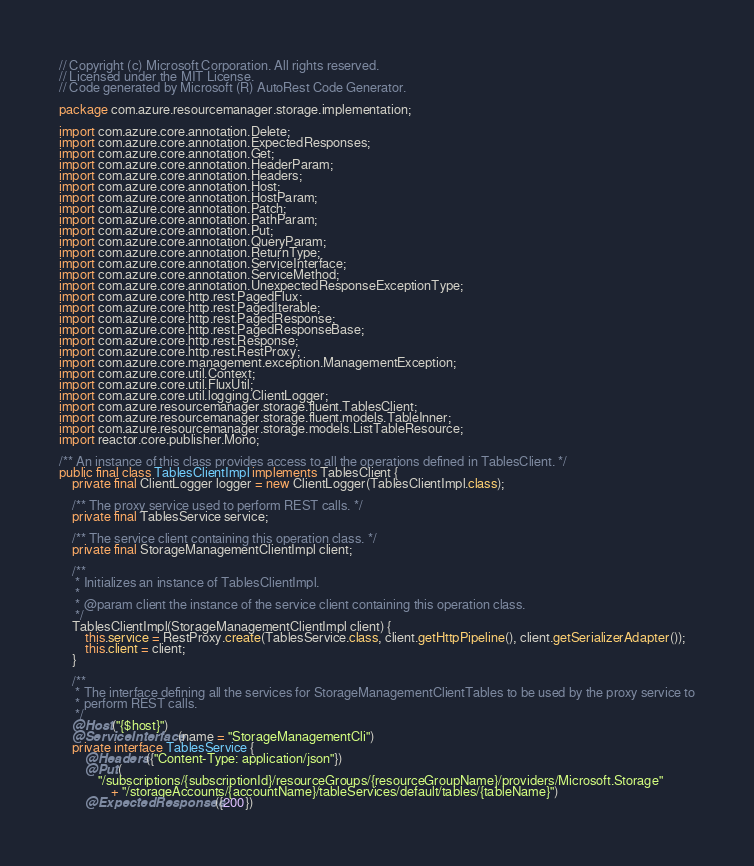Convert code to text. <code><loc_0><loc_0><loc_500><loc_500><_Java_>// Copyright (c) Microsoft Corporation. All rights reserved.
// Licensed under the MIT License.
// Code generated by Microsoft (R) AutoRest Code Generator.

package com.azure.resourcemanager.storage.implementation;

import com.azure.core.annotation.Delete;
import com.azure.core.annotation.ExpectedResponses;
import com.azure.core.annotation.Get;
import com.azure.core.annotation.HeaderParam;
import com.azure.core.annotation.Headers;
import com.azure.core.annotation.Host;
import com.azure.core.annotation.HostParam;
import com.azure.core.annotation.Patch;
import com.azure.core.annotation.PathParam;
import com.azure.core.annotation.Put;
import com.azure.core.annotation.QueryParam;
import com.azure.core.annotation.ReturnType;
import com.azure.core.annotation.ServiceInterface;
import com.azure.core.annotation.ServiceMethod;
import com.azure.core.annotation.UnexpectedResponseExceptionType;
import com.azure.core.http.rest.PagedFlux;
import com.azure.core.http.rest.PagedIterable;
import com.azure.core.http.rest.PagedResponse;
import com.azure.core.http.rest.PagedResponseBase;
import com.azure.core.http.rest.Response;
import com.azure.core.http.rest.RestProxy;
import com.azure.core.management.exception.ManagementException;
import com.azure.core.util.Context;
import com.azure.core.util.FluxUtil;
import com.azure.core.util.logging.ClientLogger;
import com.azure.resourcemanager.storage.fluent.TablesClient;
import com.azure.resourcemanager.storage.fluent.models.TableInner;
import com.azure.resourcemanager.storage.models.ListTableResource;
import reactor.core.publisher.Mono;

/** An instance of this class provides access to all the operations defined in TablesClient. */
public final class TablesClientImpl implements TablesClient {
    private final ClientLogger logger = new ClientLogger(TablesClientImpl.class);

    /** The proxy service used to perform REST calls. */
    private final TablesService service;

    /** The service client containing this operation class. */
    private final StorageManagementClientImpl client;

    /**
     * Initializes an instance of TablesClientImpl.
     *
     * @param client the instance of the service client containing this operation class.
     */
    TablesClientImpl(StorageManagementClientImpl client) {
        this.service = RestProxy.create(TablesService.class, client.getHttpPipeline(), client.getSerializerAdapter());
        this.client = client;
    }

    /**
     * The interface defining all the services for StorageManagementClientTables to be used by the proxy service to
     * perform REST calls.
     */
    @Host("{$host}")
    @ServiceInterface(name = "StorageManagementCli")
    private interface TablesService {
        @Headers({"Content-Type: application/json"})
        @Put(
            "/subscriptions/{subscriptionId}/resourceGroups/{resourceGroupName}/providers/Microsoft.Storage"
                + "/storageAccounts/{accountName}/tableServices/default/tables/{tableName}")
        @ExpectedResponses({200})</code> 